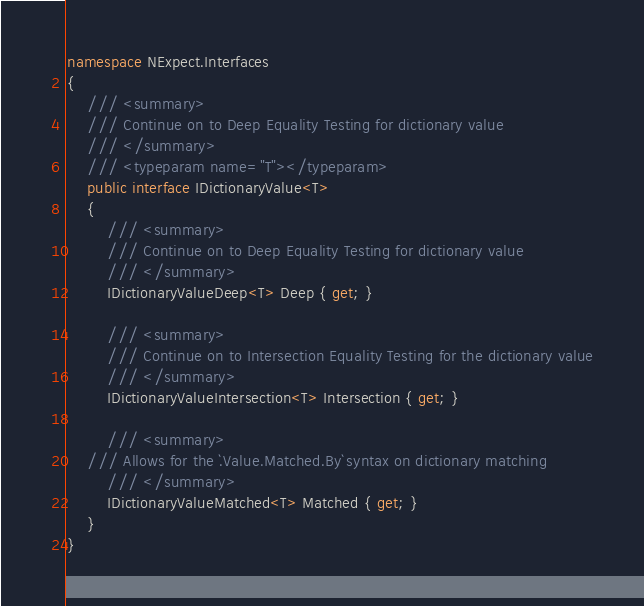Convert code to text. <code><loc_0><loc_0><loc_500><loc_500><_C#_>namespace NExpect.Interfaces
{
    /// <summary>
    /// Continue on to Deep Equality Testing for dictionary value
    /// </summary>
    /// <typeparam name="T"></typeparam>
    public interface IDictionaryValue<T>
    {
        /// <summary>
        /// Continue on to Deep Equality Testing for dictionary value
        /// </summary>
        IDictionaryValueDeep<T> Deep { get; }

        /// <summary>
        /// Continue on to Intersection Equality Testing for the dictionary value
        /// </summary>
        IDictionaryValueIntersection<T> Intersection { get; }

        /// <summary>
    /// Allows for the `.Value.Matched.By` syntax on dictionary matching
        /// </summary>
        IDictionaryValueMatched<T> Matched { get; }
    }
}</code> 